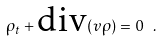<formula> <loc_0><loc_0><loc_500><loc_500>\rho _ { t } + \text {div} ( v \rho ) = 0 \ .</formula> 